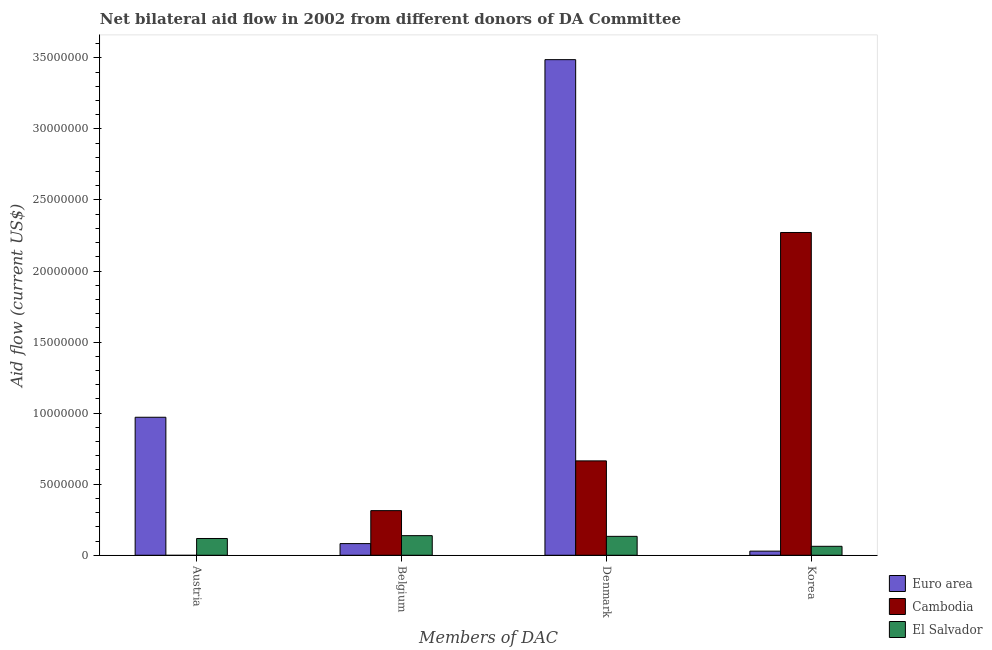How many different coloured bars are there?
Provide a short and direct response. 3. Are the number of bars per tick equal to the number of legend labels?
Provide a short and direct response. No. Are the number of bars on each tick of the X-axis equal?
Provide a short and direct response. No. How many bars are there on the 1st tick from the left?
Keep it short and to the point. 2. What is the amount of aid given by korea in Euro area?
Ensure brevity in your answer.  2.90e+05. Across all countries, what is the maximum amount of aid given by korea?
Your response must be concise. 2.27e+07. Across all countries, what is the minimum amount of aid given by korea?
Ensure brevity in your answer.  2.90e+05. What is the total amount of aid given by denmark in the graph?
Offer a terse response. 4.28e+07. What is the difference between the amount of aid given by belgium in El Salvador and that in Cambodia?
Make the answer very short. -1.76e+06. What is the difference between the amount of aid given by korea in Cambodia and the amount of aid given by austria in Euro area?
Keep it short and to the point. 1.30e+07. What is the average amount of aid given by austria per country?
Make the answer very short. 3.63e+06. What is the difference between the amount of aid given by korea and amount of aid given by austria in El Salvador?
Offer a very short reply. -5.50e+05. In how many countries, is the amount of aid given by korea greater than 25000000 US$?
Provide a succinct answer. 0. What is the ratio of the amount of aid given by denmark in Euro area to that in El Salvador?
Make the answer very short. 26.22. Is the amount of aid given by austria in Euro area less than that in El Salvador?
Your answer should be compact. No. What is the difference between the highest and the second highest amount of aid given by belgium?
Your response must be concise. 1.76e+06. What is the difference between the highest and the lowest amount of aid given by korea?
Offer a very short reply. 2.24e+07. In how many countries, is the amount of aid given by belgium greater than the average amount of aid given by belgium taken over all countries?
Offer a very short reply. 1. Is the sum of the amount of aid given by austria in Euro area and El Salvador greater than the maximum amount of aid given by belgium across all countries?
Your response must be concise. Yes. What is the difference between two consecutive major ticks on the Y-axis?
Your answer should be compact. 5.00e+06. How many legend labels are there?
Provide a succinct answer. 3. How are the legend labels stacked?
Provide a short and direct response. Vertical. What is the title of the graph?
Your answer should be compact. Net bilateral aid flow in 2002 from different donors of DA Committee. Does "Tanzania" appear as one of the legend labels in the graph?
Your response must be concise. No. What is the label or title of the X-axis?
Keep it short and to the point. Members of DAC. What is the Aid flow (current US$) in Euro area in Austria?
Ensure brevity in your answer.  9.71e+06. What is the Aid flow (current US$) in El Salvador in Austria?
Your answer should be very brief. 1.18e+06. What is the Aid flow (current US$) in Euro area in Belgium?
Provide a succinct answer. 8.20e+05. What is the Aid flow (current US$) of Cambodia in Belgium?
Give a very brief answer. 3.14e+06. What is the Aid flow (current US$) of El Salvador in Belgium?
Offer a terse response. 1.38e+06. What is the Aid flow (current US$) of Euro area in Denmark?
Give a very brief answer. 3.49e+07. What is the Aid flow (current US$) in Cambodia in Denmark?
Provide a short and direct response. 6.64e+06. What is the Aid flow (current US$) in El Salvador in Denmark?
Ensure brevity in your answer.  1.33e+06. What is the Aid flow (current US$) of Cambodia in Korea?
Your answer should be compact. 2.27e+07. What is the Aid flow (current US$) in El Salvador in Korea?
Keep it short and to the point. 6.30e+05. Across all Members of DAC, what is the maximum Aid flow (current US$) of Euro area?
Provide a short and direct response. 3.49e+07. Across all Members of DAC, what is the maximum Aid flow (current US$) of Cambodia?
Provide a succinct answer. 2.27e+07. Across all Members of DAC, what is the maximum Aid flow (current US$) of El Salvador?
Your answer should be compact. 1.38e+06. Across all Members of DAC, what is the minimum Aid flow (current US$) of Cambodia?
Ensure brevity in your answer.  0. Across all Members of DAC, what is the minimum Aid flow (current US$) of El Salvador?
Provide a short and direct response. 6.30e+05. What is the total Aid flow (current US$) in Euro area in the graph?
Provide a succinct answer. 4.57e+07. What is the total Aid flow (current US$) of Cambodia in the graph?
Offer a terse response. 3.25e+07. What is the total Aid flow (current US$) of El Salvador in the graph?
Provide a succinct answer. 4.52e+06. What is the difference between the Aid flow (current US$) of Euro area in Austria and that in Belgium?
Provide a short and direct response. 8.89e+06. What is the difference between the Aid flow (current US$) in Euro area in Austria and that in Denmark?
Provide a short and direct response. -2.52e+07. What is the difference between the Aid flow (current US$) of El Salvador in Austria and that in Denmark?
Provide a succinct answer. -1.50e+05. What is the difference between the Aid flow (current US$) in Euro area in Austria and that in Korea?
Your answer should be very brief. 9.42e+06. What is the difference between the Aid flow (current US$) of Euro area in Belgium and that in Denmark?
Give a very brief answer. -3.40e+07. What is the difference between the Aid flow (current US$) of Cambodia in Belgium and that in Denmark?
Give a very brief answer. -3.50e+06. What is the difference between the Aid flow (current US$) of Euro area in Belgium and that in Korea?
Give a very brief answer. 5.30e+05. What is the difference between the Aid flow (current US$) in Cambodia in Belgium and that in Korea?
Your answer should be very brief. -1.96e+07. What is the difference between the Aid flow (current US$) of El Salvador in Belgium and that in Korea?
Give a very brief answer. 7.50e+05. What is the difference between the Aid flow (current US$) in Euro area in Denmark and that in Korea?
Your answer should be compact. 3.46e+07. What is the difference between the Aid flow (current US$) in Cambodia in Denmark and that in Korea?
Give a very brief answer. -1.61e+07. What is the difference between the Aid flow (current US$) of Euro area in Austria and the Aid flow (current US$) of Cambodia in Belgium?
Provide a succinct answer. 6.57e+06. What is the difference between the Aid flow (current US$) of Euro area in Austria and the Aid flow (current US$) of El Salvador in Belgium?
Provide a short and direct response. 8.33e+06. What is the difference between the Aid flow (current US$) of Euro area in Austria and the Aid flow (current US$) of Cambodia in Denmark?
Your answer should be compact. 3.07e+06. What is the difference between the Aid flow (current US$) of Euro area in Austria and the Aid flow (current US$) of El Salvador in Denmark?
Ensure brevity in your answer.  8.38e+06. What is the difference between the Aid flow (current US$) of Euro area in Austria and the Aid flow (current US$) of Cambodia in Korea?
Keep it short and to the point. -1.30e+07. What is the difference between the Aid flow (current US$) of Euro area in Austria and the Aid flow (current US$) of El Salvador in Korea?
Offer a very short reply. 9.08e+06. What is the difference between the Aid flow (current US$) of Euro area in Belgium and the Aid flow (current US$) of Cambodia in Denmark?
Your answer should be compact. -5.82e+06. What is the difference between the Aid flow (current US$) of Euro area in Belgium and the Aid flow (current US$) of El Salvador in Denmark?
Offer a terse response. -5.10e+05. What is the difference between the Aid flow (current US$) in Cambodia in Belgium and the Aid flow (current US$) in El Salvador in Denmark?
Give a very brief answer. 1.81e+06. What is the difference between the Aid flow (current US$) in Euro area in Belgium and the Aid flow (current US$) in Cambodia in Korea?
Your response must be concise. -2.19e+07. What is the difference between the Aid flow (current US$) in Euro area in Belgium and the Aid flow (current US$) in El Salvador in Korea?
Ensure brevity in your answer.  1.90e+05. What is the difference between the Aid flow (current US$) of Cambodia in Belgium and the Aid flow (current US$) of El Salvador in Korea?
Your answer should be very brief. 2.51e+06. What is the difference between the Aid flow (current US$) of Euro area in Denmark and the Aid flow (current US$) of Cambodia in Korea?
Your answer should be very brief. 1.22e+07. What is the difference between the Aid flow (current US$) in Euro area in Denmark and the Aid flow (current US$) in El Salvador in Korea?
Give a very brief answer. 3.42e+07. What is the difference between the Aid flow (current US$) of Cambodia in Denmark and the Aid flow (current US$) of El Salvador in Korea?
Your answer should be very brief. 6.01e+06. What is the average Aid flow (current US$) in Euro area per Members of DAC?
Your response must be concise. 1.14e+07. What is the average Aid flow (current US$) of Cambodia per Members of DAC?
Ensure brevity in your answer.  8.12e+06. What is the average Aid flow (current US$) in El Salvador per Members of DAC?
Offer a terse response. 1.13e+06. What is the difference between the Aid flow (current US$) of Euro area and Aid flow (current US$) of El Salvador in Austria?
Provide a short and direct response. 8.53e+06. What is the difference between the Aid flow (current US$) of Euro area and Aid flow (current US$) of Cambodia in Belgium?
Your answer should be compact. -2.32e+06. What is the difference between the Aid flow (current US$) of Euro area and Aid flow (current US$) of El Salvador in Belgium?
Offer a terse response. -5.60e+05. What is the difference between the Aid flow (current US$) in Cambodia and Aid flow (current US$) in El Salvador in Belgium?
Your answer should be very brief. 1.76e+06. What is the difference between the Aid flow (current US$) in Euro area and Aid flow (current US$) in Cambodia in Denmark?
Your answer should be very brief. 2.82e+07. What is the difference between the Aid flow (current US$) in Euro area and Aid flow (current US$) in El Salvador in Denmark?
Ensure brevity in your answer.  3.35e+07. What is the difference between the Aid flow (current US$) of Cambodia and Aid flow (current US$) of El Salvador in Denmark?
Ensure brevity in your answer.  5.31e+06. What is the difference between the Aid flow (current US$) in Euro area and Aid flow (current US$) in Cambodia in Korea?
Your response must be concise. -2.24e+07. What is the difference between the Aid flow (current US$) in Cambodia and Aid flow (current US$) in El Salvador in Korea?
Offer a terse response. 2.21e+07. What is the ratio of the Aid flow (current US$) in Euro area in Austria to that in Belgium?
Offer a very short reply. 11.84. What is the ratio of the Aid flow (current US$) of El Salvador in Austria to that in Belgium?
Give a very brief answer. 0.86. What is the ratio of the Aid flow (current US$) in Euro area in Austria to that in Denmark?
Your answer should be compact. 0.28. What is the ratio of the Aid flow (current US$) in El Salvador in Austria to that in Denmark?
Keep it short and to the point. 0.89. What is the ratio of the Aid flow (current US$) of Euro area in Austria to that in Korea?
Offer a very short reply. 33.48. What is the ratio of the Aid flow (current US$) of El Salvador in Austria to that in Korea?
Provide a short and direct response. 1.87. What is the ratio of the Aid flow (current US$) of Euro area in Belgium to that in Denmark?
Offer a terse response. 0.02. What is the ratio of the Aid flow (current US$) of Cambodia in Belgium to that in Denmark?
Offer a very short reply. 0.47. What is the ratio of the Aid flow (current US$) in El Salvador in Belgium to that in Denmark?
Give a very brief answer. 1.04. What is the ratio of the Aid flow (current US$) in Euro area in Belgium to that in Korea?
Your answer should be compact. 2.83. What is the ratio of the Aid flow (current US$) of Cambodia in Belgium to that in Korea?
Offer a very short reply. 0.14. What is the ratio of the Aid flow (current US$) of El Salvador in Belgium to that in Korea?
Ensure brevity in your answer.  2.19. What is the ratio of the Aid flow (current US$) in Euro area in Denmark to that in Korea?
Your response must be concise. 120.24. What is the ratio of the Aid flow (current US$) in Cambodia in Denmark to that in Korea?
Offer a very short reply. 0.29. What is the ratio of the Aid flow (current US$) in El Salvador in Denmark to that in Korea?
Provide a succinct answer. 2.11. What is the difference between the highest and the second highest Aid flow (current US$) of Euro area?
Make the answer very short. 2.52e+07. What is the difference between the highest and the second highest Aid flow (current US$) of Cambodia?
Your answer should be very brief. 1.61e+07. What is the difference between the highest and the lowest Aid flow (current US$) of Euro area?
Offer a terse response. 3.46e+07. What is the difference between the highest and the lowest Aid flow (current US$) of Cambodia?
Offer a very short reply. 2.27e+07. What is the difference between the highest and the lowest Aid flow (current US$) in El Salvador?
Your answer should be compact. 7.50e+05. 